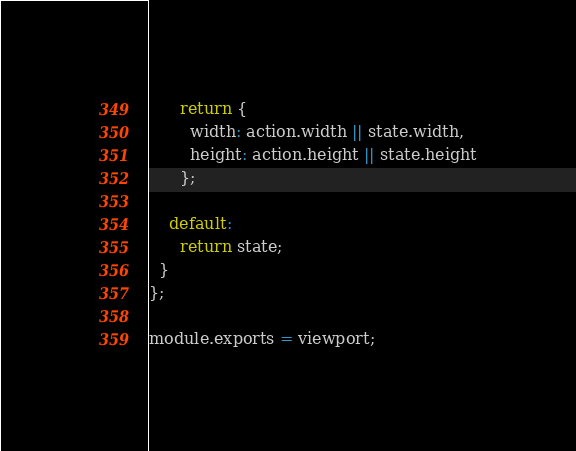Convert code to text. <code><loc_0><loc_0><loc_500><loc_500><_JavaScript_>      return {
        width: action.width || state.width,
        height: action.height || state.height
      };
    
    default:
      return state;
  }
};

module.exports = viewport;
</code> 